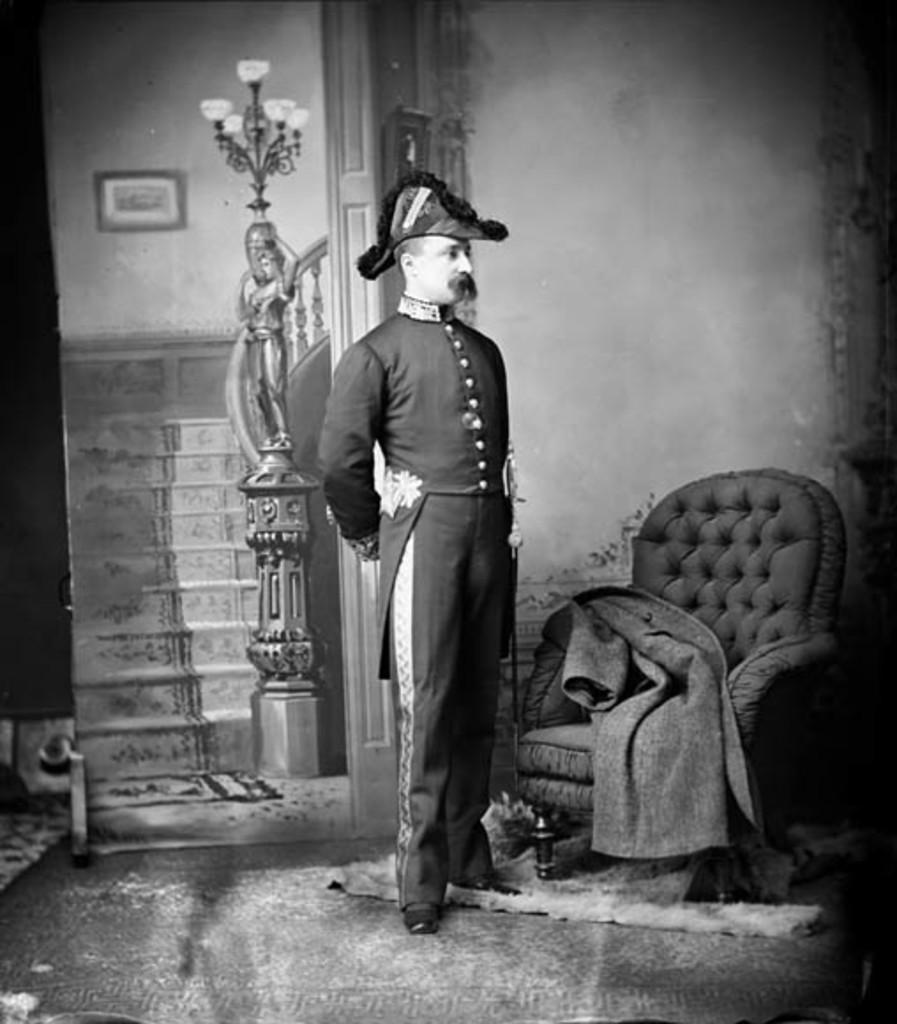Can you describe this image briefly? As we can see in the image there is a wall, chair, a person standing over here, statue, photo frame, stairs and mats. 